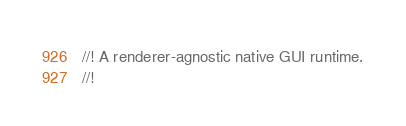<code> <loc_0><loc_0><loc_500><loc_500><_Rust_>//! A renderer-agnostic native GUI runtime.
//!</code> 